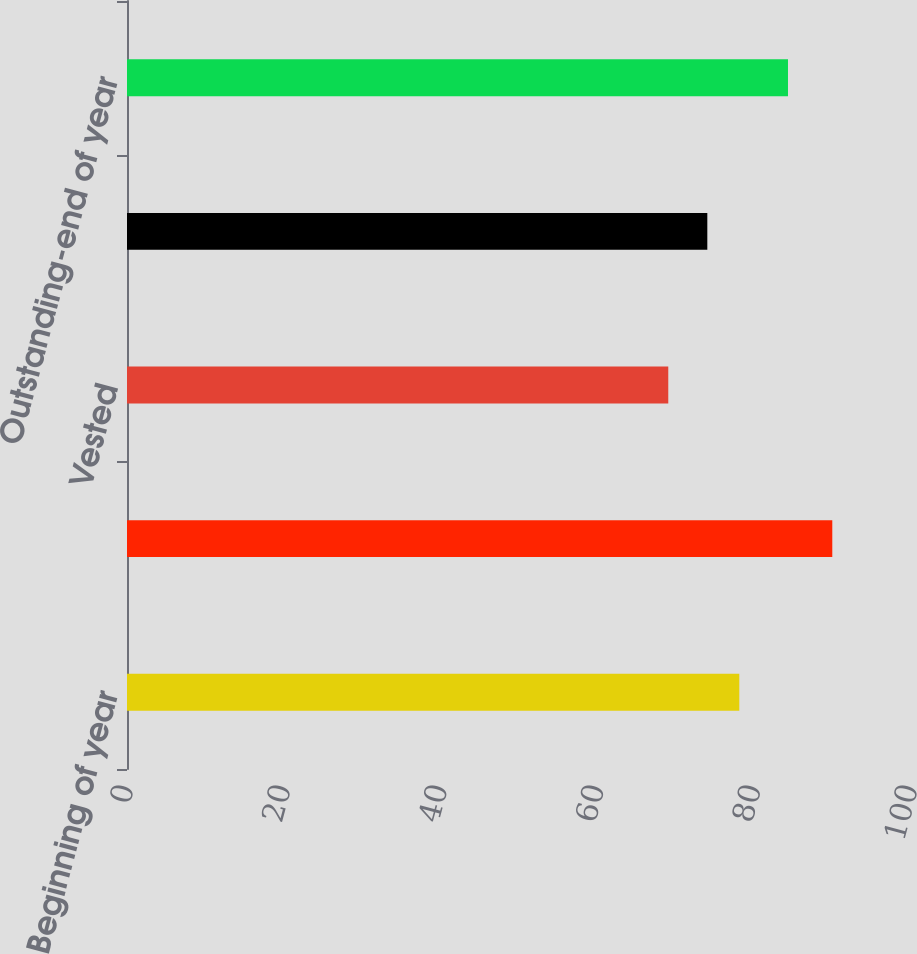Convert chart to OTSL. <chart><loc_0><loc_0><loc_500><loc_500><bar_chart><fcel>Beginning of year<fcel>Granted<fcel>Vested<fcel>Performance adjustment<fcel>Outstanding-end of year<nl><fcel>78.1<fcel>89.96<fcel>69.04<fcel>74.02<fcel>84.31<nl></chart> 